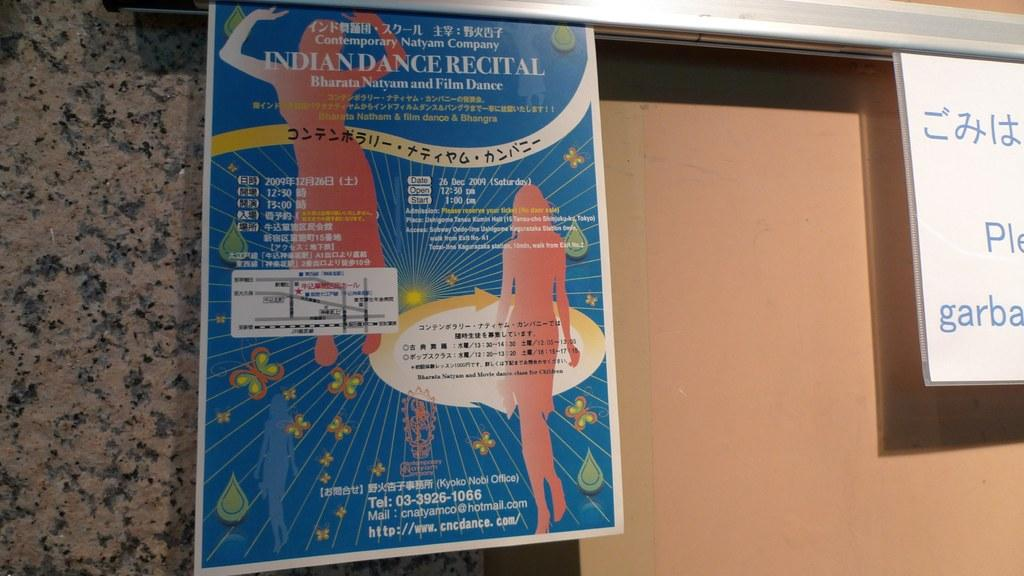<image>
Give a short and clear explanation of the subsequent image. Contemporary Natyam Company Indian Dance Recital poster being displayed on a board. 